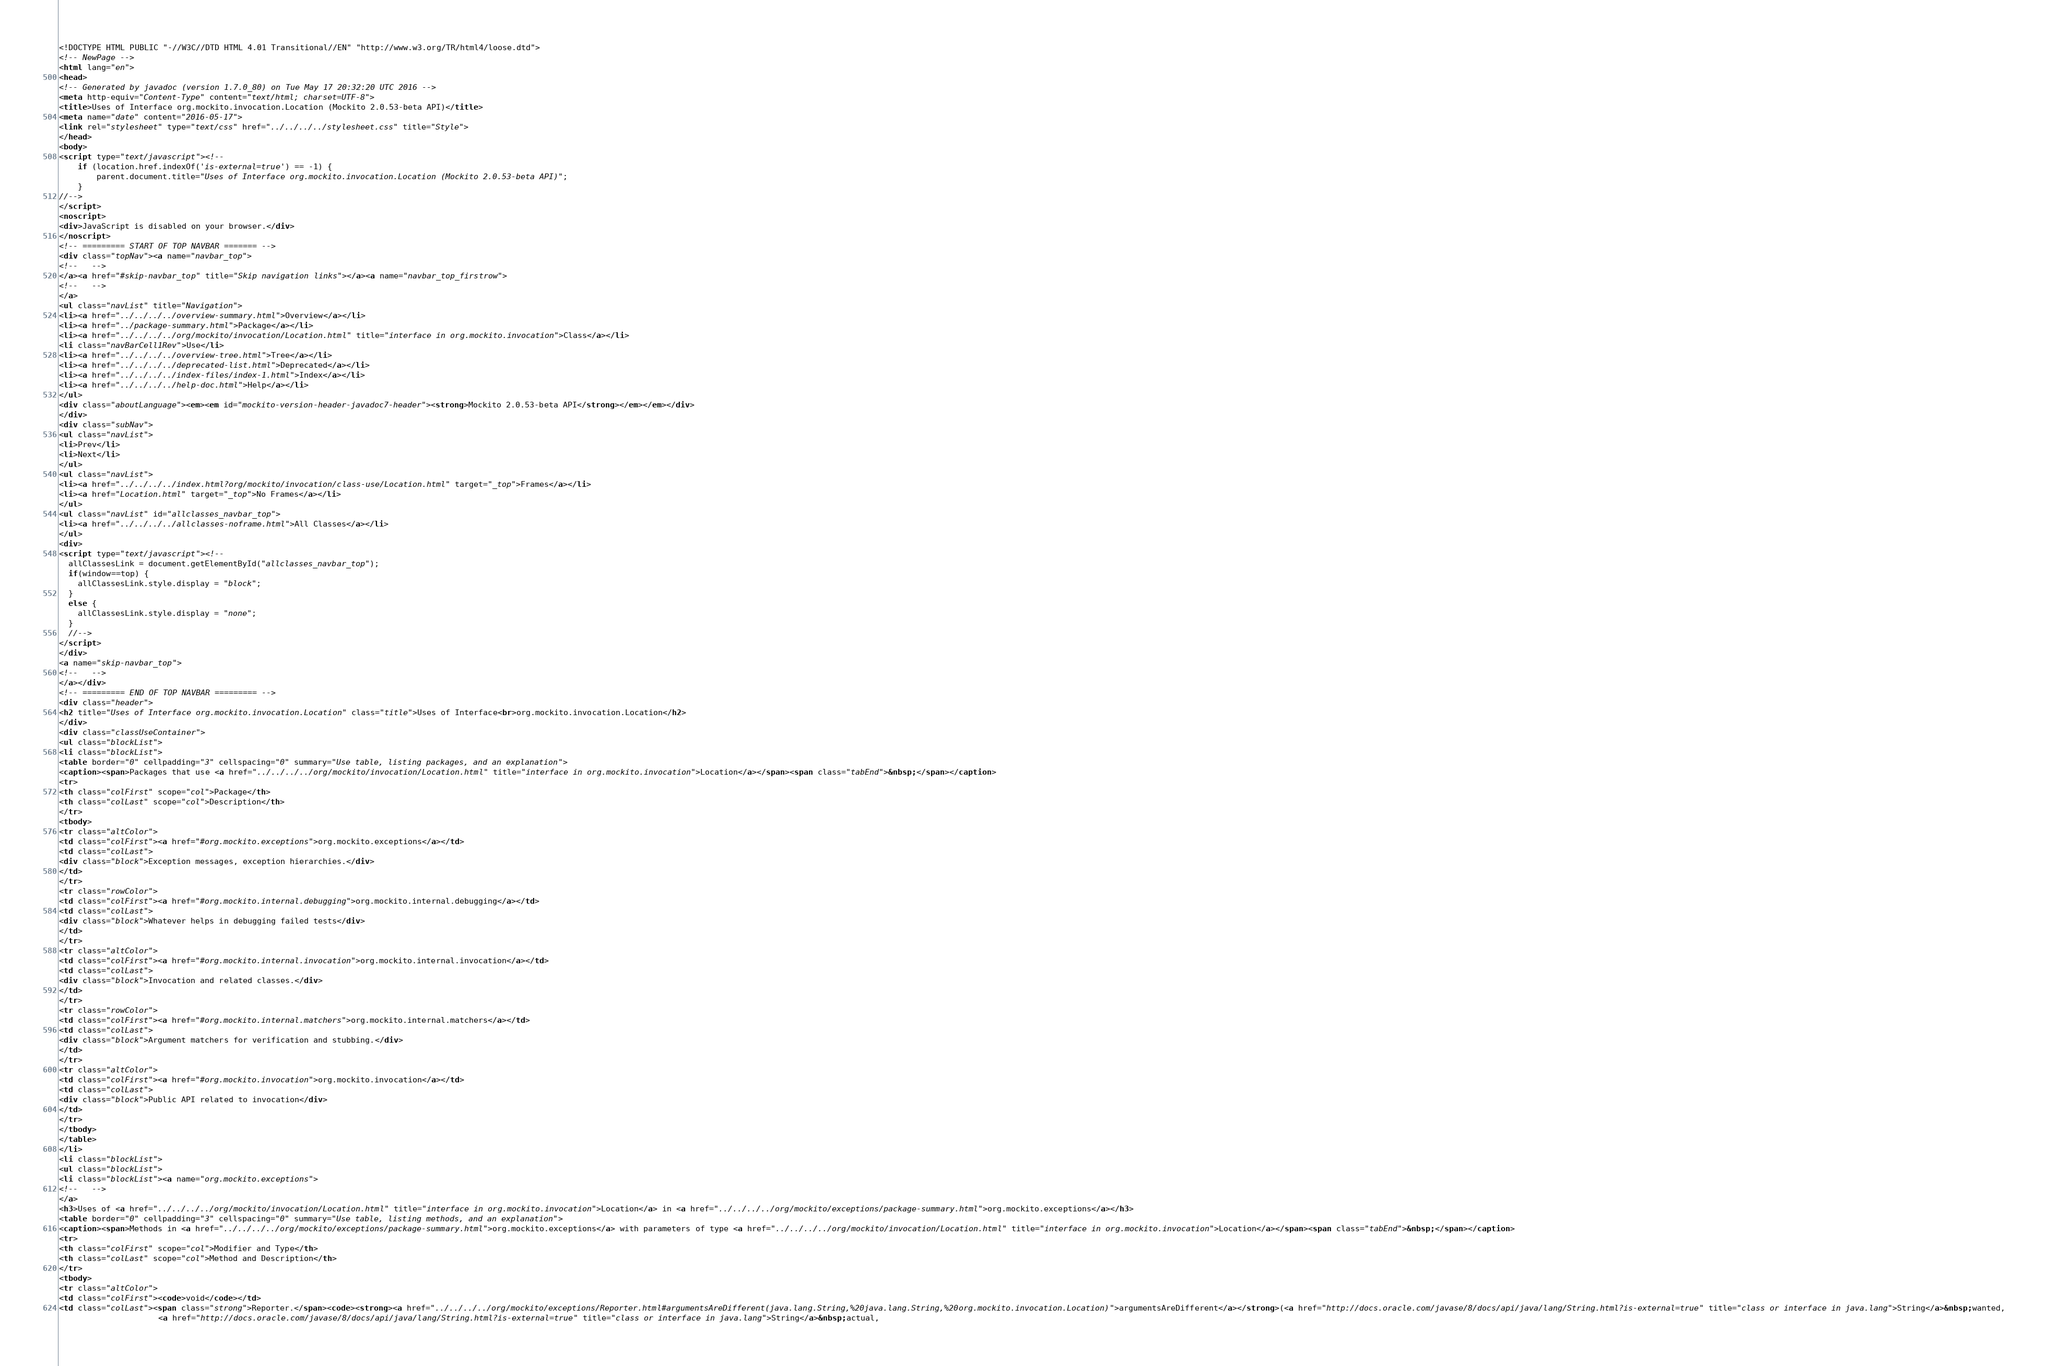<code> <loc_0><loc_0><loc_500><loc_500><_HTML_><!DOCTYPE HTML PUBLIC "-//W3C//DTD HTML 4.01 Transitional//EN" "http://www.w3.org/TR/html4/loose.dtd">
<!-- NewPage -->
<html lang="en">
<head>
<!-- Generated by javadoc (version 1.7.0_80) on Tue May 17 20:32:20 UTC 2016 -->
<meta http-equiv="Content-Type" content="text/html; charset=UTF-8">
<title>Uses of Interface org.mockito.invocation.Location (Mockito 2.0.53-beta API)</title>
<meta name="date" content="2016-05-17">
<link rel="stylesheet" type="text/css" href="../../../../stylesheet.css" title="Style">
</head>
<body>
<script type="text/javascript"><!--
    if (location.href.indexOf('is-external=true') == -1) {
        parent.document.title="Uses of Interface org.mockito.invocation.Location (Mockito 2.0.53-beta API)";
    }
//-->
</script>
<noscript>
<div>JavaScript is disabled on your browser.</div>
</noscript>
<!-- ========= START OF TOP NAVBAR ======= -->
<div class="topNav"><a name="navbar_top">
<!--   -->
</a><a href="#skip-navbar_top" title="Skip navigation links"></a><a name="navbar_top_firstrow">
<!--   -->
</a>
<ul class="navList" title="Navigation">
<li><a href="../../../../overview-summary.html">Overview</a></li>
<li><a href="../package-summary.html">Package</a></li>
<li><a href="../../../../org/mockito/invocation/Location.html" title="interface in org.mockito.invocation">Class</a></li>
<li class="navBarCell1Rev">Use</li>
<li><a href="../../../../overview-tree.html">Tree</a></li>
<li><a href="../../../../deprecated-list.html">Deprecated</a></li>
<li><a href="../../../../index-files/index-1.html">Index</a></li>
<li><a href="../../../../help-doc.html">Help</a></li>
</ul>
<div class="aboutLanguage"><em><em id="mockito-version-header-javadoc7-header"><strong>Mockito 2.0.53-beta API</strong></em></em></div>
</div>
<div class="subNav">
<ul class="navList">
<li>Prev</li>
<li>Next</li>
</ul>
<ul class="navList">
<li><a href="../../../../index.html?org/mockito/invocation/class-use/Location.html" target="_top">Frames</a></li>
<li><a href="Location.html" target="_top">No Frames</a></li>
</ul>
<ul class="navList" id="allclasses_navbar_top">
<li><a href="../../../../allclasses-noframe.html">All Classes</a></li>
</ul>
<div>
<script type="text/javascript"><!--
  allClassesLink = document.getElementById("allclasses_navbar_top");
  if(window==top) {
    allClassesLink.style.display = "block";
  }
  else {
    allClassesLink.style.display = "none";
  }
  //-->
</script>
</div>
<a name="skip-navbar_top">
<!--   -->
</a></div>
<!-- ========= END OF TOP NAVBAR ========= -->
<div class="header">
<h2 title="Uses of Interface org.mockito.invocation.Location" class="title">Uses of Interface<br>org.mockito.invocation.Location</h2>
</div>
<div class="classUseContainer">
<ul class="blockList">
<li class="blockList">
<table border="0" cellpadding="3" cellspacing="0" summary="Use table, listing packages, and an explanation">
<caption><span>Packages that use <a href="../../../../org/mockito/invocation/Location.html" title="interface in org.mockito.invocation">Location</a></span><span class="tabEnd">&nbsp;</span></caption>
<tr>
<th class="colFirst" scope="col">Package</th>
<th class="colLast" scope="col">Description</th>
</tr>
<tbody>
<tr class="altColor">
<td class="colFirst"><a href="#org.mockito.exceptions">org.mockito.exceptions</a></td>
<td class="colLast">
<div class="block">Exception messages, exception hierarchies.</div>
</td>
</tr>
<tr class="rowColor">
<td class="colFirst"><a href="#org.mockito.internal.debugging">org.mockito.internal.debugging</a></td>
<td class="colLast">
<div class="block">Whatever helps in debugging failed tests</div>
</td>
</tr>
<tr class="altColor">
<td class="colFirst"><a href="#org.mockito.internal.invocation">org.mockito.internal.invocation</a></td>
<td class="colLast">
<div class="block">Invocation and related classes.</div>
</td>
</tr>
<tr class="rowColor">
<td class="colFirst"><a href="#org.mockito.internal.matchers">org.mockito.internal.matchers</a></td>
<td class="colLast">
<div class="block">Argument matchers for verification and stubbing.</div>
</td>
</tr>
<tr class="altColor">
<td class="colFirst"><a href="#org.mockito.invocation">org.mockito.invocation</a></td>
<td class="colLast">
<div class="block">Public API related to invocation</div>
</td>
</tr>
</tbody>
</table>
</li>
<li class="blockList">
<ul class="blockList">
<li class="blockList"><a name="org.mockito.exceptions">
<!--   -->
</a>
<h3>Uses of <a href="../../../../org/mockito/invocation/Location.html" title="interface in org.mockito.invocation">Location</a> in <a href="../../../../org/mockito/exceptions/package-summary.html">org.mockito.exceptions</a></h3>
<table border="0" cellpadding="3" cellspacing="0" summary="Use table, listing methods, and an explanation">
<caption><span>Methods in <a href="../../../../org/mockito/exceptions/package-summary.html">org.mockito.exceptions</a> with parameters of type <a href="../../../../org/mockito/invocation/Location.html" title="interface in org.mockito.invocation">Location</a></span><span class="tabEnd">&nbsp;</span></caption>
<tr>
<th class="colFirst" scope="col">Modifier and Type</th>
<th class="colLast" scope="col">Method and Description</th>
</tr>
<tbody>
<tr class="altColor">
<td class="colFirst"><code>void</code></td>
<td class="colLast"><span class="strong">Reporter.</span><code><strong><a href="../../../../org/mockito/exceptions/Reporter.html#argumentsAreDifferent(java.lang.String,%20java.lang.String,%20org.mockito.invocation.Location)">argumentsAreDifferent</a></strong>(<a href="http://docs.oracle.com/javase/8/docs/api/java/lang/String.html?is-external=true" title="class or interface in java.lang">String</a>&nbsp;wanted,
                     <a href="http://docs.oracle.com/javase/8/docs/api/java/lang/String.html?is-external=true" title="class or interface in java.lang">String</a>&nbsp;actual,</code> 